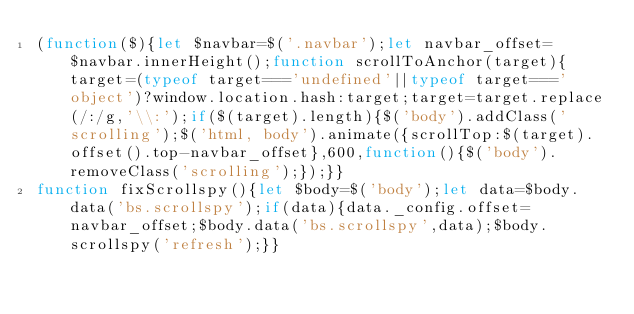<code> <loc_0><loc_0><loc_500><loc_500><_JavaScript_>(function($){let $navbar=$('.navbar');let navbar_offset=$navbar.innerHeight();function scrollToAnchor(target){target=(typeof target==='undefined'||typeof target==='object')?window.location.hash:target;target=target.replace(/:/g,'\\:');if($(target).length){$('body').addClass('scrolling');$('html, body').animate({scrollTop:$(target).offset().top-navbar_offset},600,function(){$('body').removeClass('scrolling');});}}
function fixScrollspy(){let $body=$('body');let data=$body.data('bs.scrollspy');if(data){data._config.offset=navbar_offset;$body.data('bs.scrollspy',data);$body.scrollspy('refresh');}}</code> 